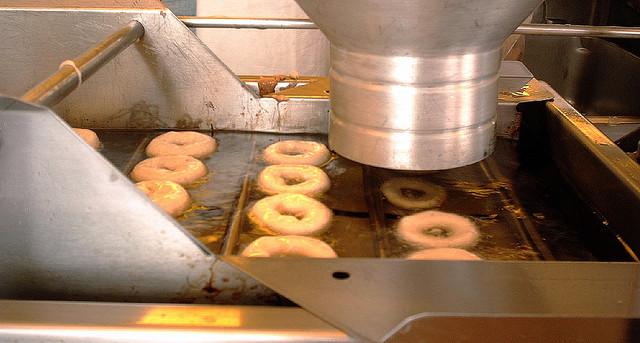Are these edible objects high in fat?
Write a very short answer. Yes. Are these items deep fried?
Give a very brief answer. Yes. Could these be doughnuts?
Write a very short answer. Yes. 